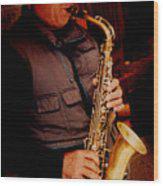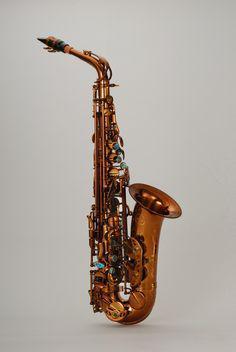The first image is the image on the left, the second image is the image on the right. For the images shown, is this caption "The saxophone in the image on the left is on a stand." true? Answer yes or no. No. 